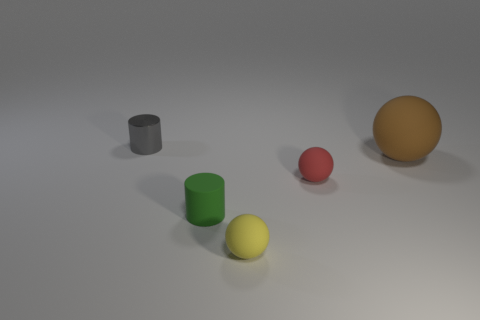There is a small cylinder right of the gray metallic object; is its color the same as the matte thing on the right side of the tiny red ball? No, the small cylinder to the right of the gray metallic object is green, which differs from the matte yellow object located to the right of the tiny red ball. 